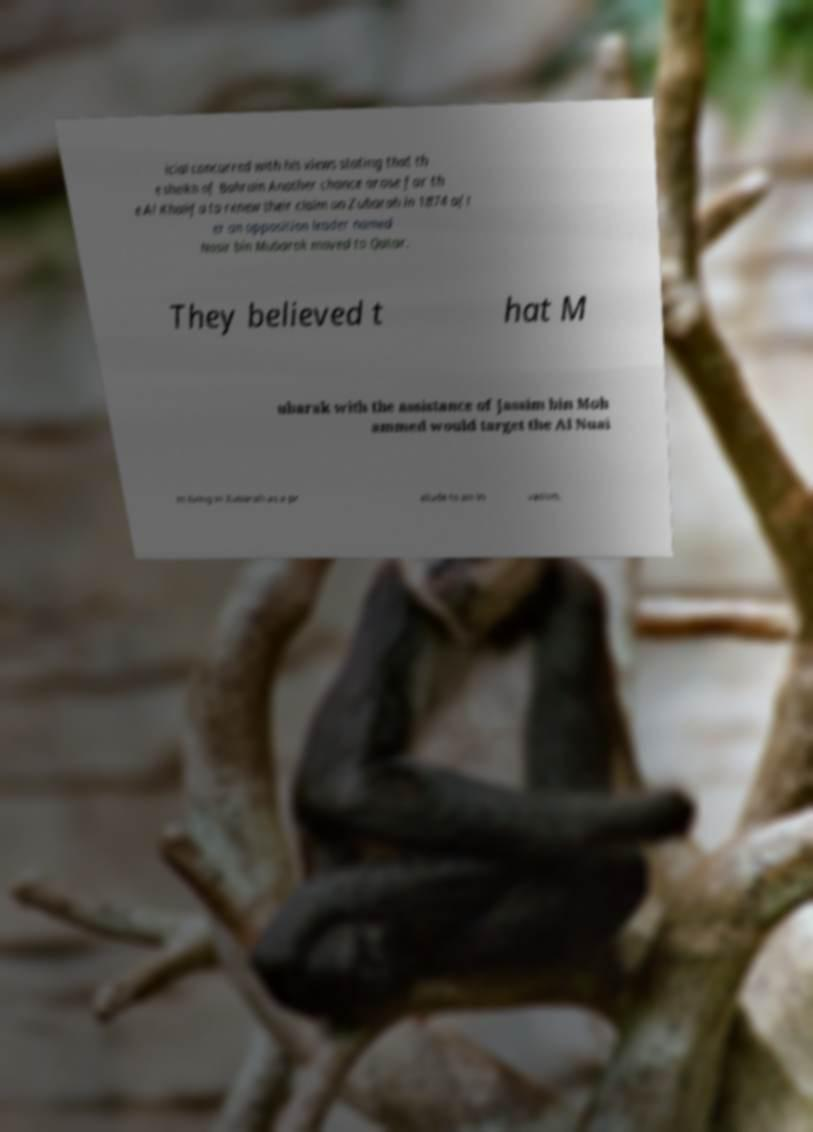What messages or text are displayed in this image? I need them in a readable, typed format. icial concurred with his views stating that th e sheikh of Bahrain Another chance arose for th e Al Khalifa to renew their claim on Zubarah in 1874 aft er an opposition leader named Nasir bin Mubarak moved to Qatar. They believed t hat M ubarak with the assistance of Jassim bin Moh ammed would target the Al Nuai m living in Zubarah as a pr elude to an in vasion. 